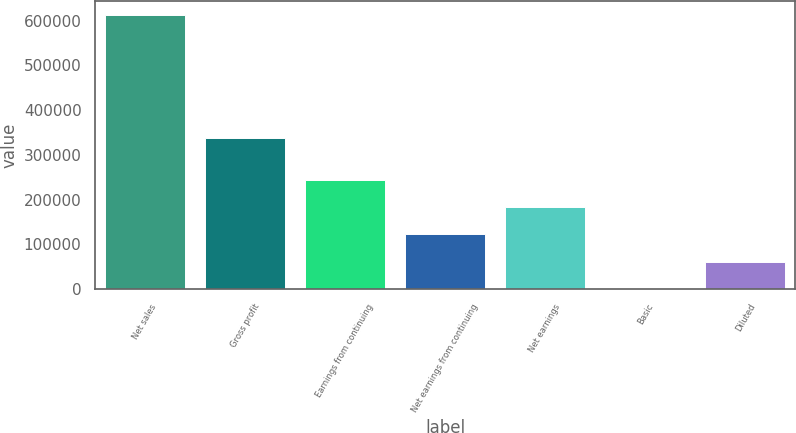Convert chart. <chart><loc_0><loc_0><loc_500><loc_500><bar_chart><fcel>Net sales<fcel>Gross profit<fcel>Earnings from continuing<fcel>Net earnings from continuing<fcel>Net earnings<fcel>Basic<fcel>Diluted<nl><fcel>612493<fcel>337452<fcel>244997<fcel>122499<fcel>183748<fcel>0.46<fcel>61249.7<nl></chart> 